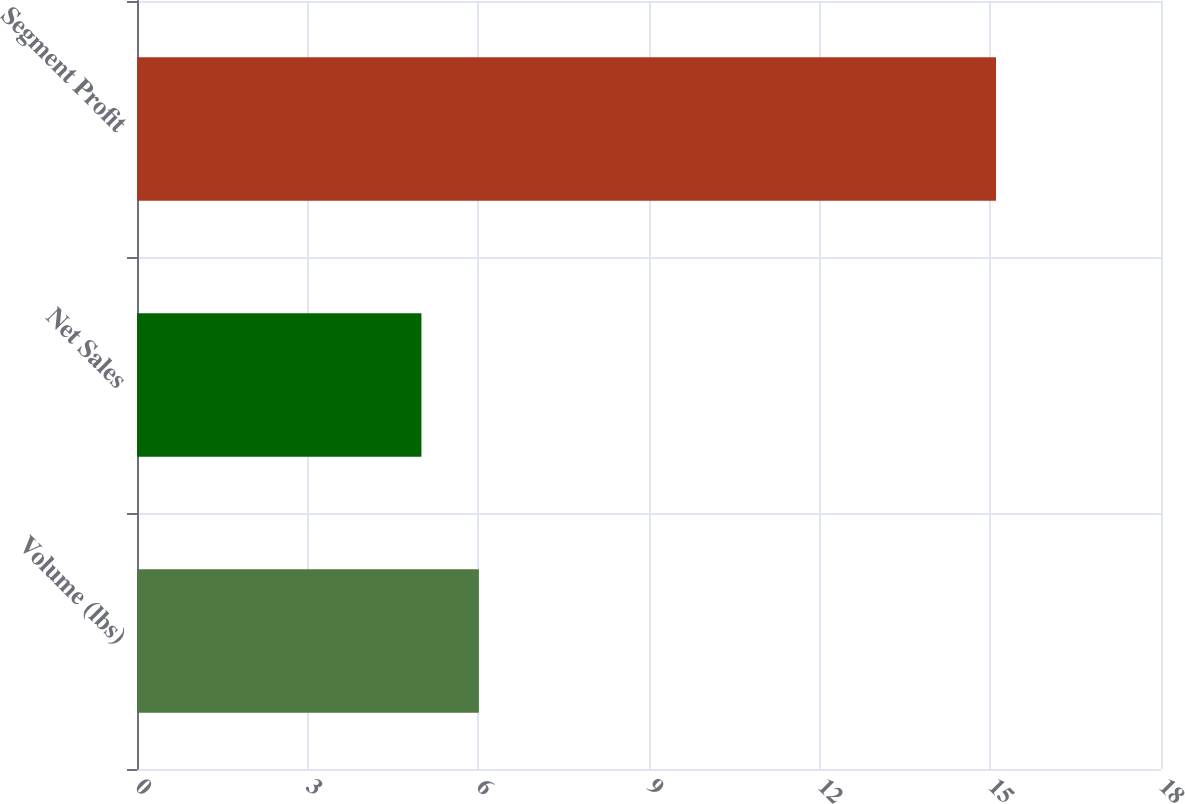<chart> <loc_0><loc_0><loc_500><loc_500><bar_chart><fcel>Volume (lbs)<fcel>Net Sales<fcel>Segment Profit<nl><fcel>6.01<fcel>5<fcel>15.1<nl></chart> 